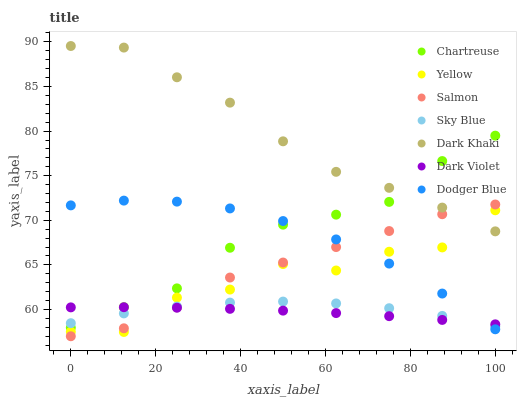Does Dark Violet have the minimum area under the curve?
Answer yes or no. Yes. Does Dark Khaki have the maximum area under the curve?
Answer yes or no. Yes. Does Dark Khaki have the minimum area under the curve?
Answer yes or no. No. Does Dark Violet have the maximum area under the curve?
Answer yes or no. No. Is Dark Violet the smoothest?
Answer yes or no. Yes. Is Yellow the roughest?
Answer yes or no. Yes. Is Dark Khaki the smoothest?
Answer yes or no. No. Is Dark Khaki the roughest?
Answer yes or no. No. Does Salmon have the lowest value?
Answer yes or no. Yes. Does Dark Violet have the lowest value?
Answer yes or no. No. Does Dark Khaki have the highest value?
Answer yes or no. Yes. Does Dark Violet have the highest value?
Answer yes or no. No. Is Dark Violet less than Dark Khaki?
Answer yes or no. Yes. Is Chartreuse greater than Yellow?
Answer yes or no. Yes. Does Dark Violet intersect Sky Blue?
Answer yes or no. Yes. Is Dark Violet less than Sky Blue?
Answer yes or no. No. Is Dark Violet greater than Sky Blue?
Answer yes or no. No. Does Dark Violet intersect Dark Khaki?
Answer yes or no. No. 